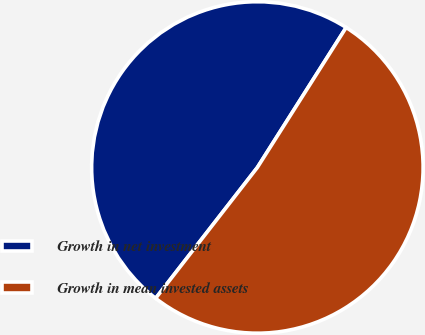<chart> <loc_0><loc_0><loc_500><loc_500><pie_chart><fcel>Growth in net investment<fcel>Growth in mean invested assets<nl><fcel>48.48%<fcel>51.52%<nl></chart> 